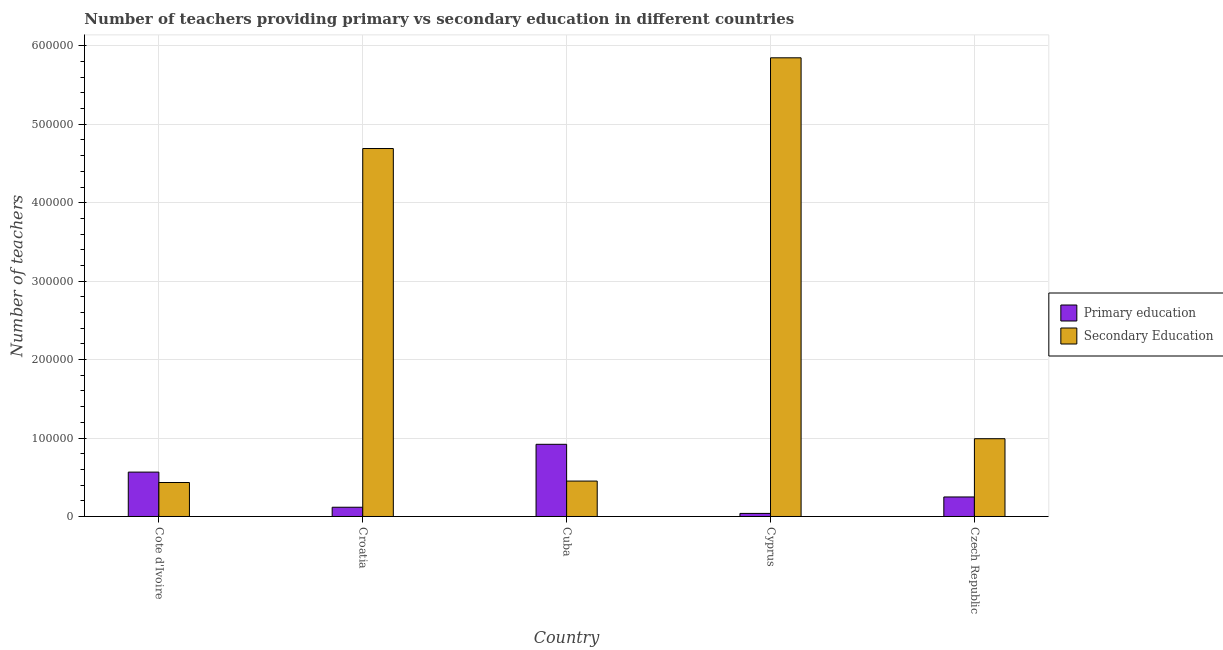How many groups of bars are there?
Provide a short and direct response. 5. How many bars are there on the 3rd tick from the right?
Your response must be concise. 2. What is the label of the 5th group of bars from the left?
Your answer should be compact. Czech Republic. In how many cases, is the number of bars for a given country not equal to the number of legend labels?
Ensure brevity in your answer.  0. What is the number of primary teachers in Cote d'Ivoire?
Provide a short and direct response. 5.66e+04. Across all countries, what is the maximum number of primary teachers?
Make the answer very short. 9.20e+04. Across all countries, what is the minimum number of primary teachers?
Ensure brevity in your answer.  3921. In which country was the number of primary teachers maximum?
Keep it short and to the point. Cuba. In which country was the number of primary teachers minimum?
Offer a terse response. Cyprus. What is the total number of secondary teachers in the graph?
Make the answer very short. 1.24e+06. What is the difference between the number of primary teachers in Cote d'Ivoire and that in Cyprus?
Offer a terse response. 5.27e+04. What is the difference between the number of primary teachers in Cyprus and the number of secondary teachers in Czech Republic?
Your answer should be compact. -9.52e+04. What is the average number of secondary teachers per country?
Provide a short and direct response. 2.48e+05. What is the difference between the number of secondary teachers and number of primary teachers in Cote d'Ivoire?
Your answer should be compact. -1.33e+04. In how many countries, is the number of primary teachers greater than 420000 ?
Your response must be concise. 0. What is the ratio of the number of secondary teachers in Croatia to that in Czech Republic?
Offer a very short reply. 4.73. Is the difference between the number of primary teachers in Cote d'Ivoire and Czech Republic greater than the difference between the number of secondary teachers in Cote d'Ivoire and Czech Republic?
Give a very brief answer. Yes. What is the difference between the highest and the second highest number of secondary teachers?
Provide a succinct answer. 1.16e+05. What is the difference between the highest and the lowest number of primary teachers?
Offer a very short reply. 8.81e+04. Is the sum of the number of primary teachers in Croatia and Cyprus greater than the maximum number of secondary teachers across all countries?
Ensure brevity in your answer.  No. What does the 2nd bar from the left in Czech Republic represents?
Your answer should be compact. Secondary Education. What does the 2nd bar from the right in Cyprus represents?
Keep it short and to the point. Primary education. Are all the bars in the graph horizontal?
Your answer should be very brief. No. How many countries are there in the graph?
Make the answer very short. 5. Are the values on the major ticks of Y-axis written in scientific E-notation?
Provide a succinct answer. No. Does the graph contain any zero values?
Your answer should be very brief. No. What is the title of the graph?
Keep it short and to the point. Number of teachers providing primary vs secondary education in different countries. What is the label or title of the X-axis?
Provide a succinct answer. Country. What is the label or title of the Y-axis?
Keep it short and to the point. Number of teachers. What is the Number of teachers of Primary education in Cote d'Ivoire?
Provide a succinct answer. 5.66e+04. What is the Number of teachers of Secondary Education in Cote d'Ivoire?
Make the answer very short. 4.33e+04. What is the Number of teachers in Primary education in Croatia?
Your answer should be compact. 1.18e+04. What is the Number of teachers in Secondary Education in Croatia?
Offer a terse response. 4.69e+05. What is the Number of teachers of Primary education in Cuba?
Ensure brevity in your answer.  9.20e+04. What is the Number of teachers of Secondary Education in Cuba?
Offer a very short reply. 4.51e+04. What is the Number of teachers in Primary education in Cyprus?
Your response must be concise. 3921. What is the Number of teachers in Secondary Education in Cyprus?
Your answer should be compact. 5.85e+05. What is the Number of teachers in Primary education in Czech Republic?
Offer a terse response. 2.49e+04. What is the Number of teachers of Secondary Education in Czech Republic?
Make the answer very short. 9.92e+04. Across all countries, what is the maximum Number of teachers of Primary education?
Offer a terse response. 9.20e+04. Across all countries, what is the maximum Number of teachers of Secondary Education?
Your answer should be very brief. 5.85e+05. Across all countries, what is the minimum Number of teachers of Primary education?
Your answer should be very brief. 3921. Across all countries, what is the minimum Number of teachers of Secondary Education?
Offer a terse response. 4.33e+04. What is the total Number of teachers in Primary education in the graph?
Your response must be concise. 1.89e+05. What is the total Number of teachers of Secondary Education in the graph?
Your response must be concise. 1.24e+06. What is the difference between the Number of teachers of Primary education in Cote d'Ivoire and that in Croatia?
Your answer should be compact. 4.48e+04. What is the difference between the Number of teachers of Secondary Education in Cote d'Ivoire and that in Croatia?
Offer a very short reply. -4.26e+05. What is the difference between the Number of teachers of Primary education in Cote d'Ivoire and that in Cuba?
Provide a succinct answer. -3.54e+04. What is the difference between the Number of teachers in Secondary Education in Cote d'Ivoire and that in Cuba?
Your answer should be very brief. -1828. What is the difference between the Number of teachers in Primary education in Cote d'Ivoire and that in Cyprus?
Offer a terse response. 5.27e+04. What is the difference between the Number of teachers of Secondary Education in Cote d'Ivoire and that in Cyprus?
Give a very brief answer. -5.41e+05. What is the difference between the Number of teachers in Primary education in Cote d'Ivoire and that in Czech Republic?
Make the answer very short. 3.17e+04. What is the difference between the Number of teachers in Secondary Education in Cote d'Ivoire and that in Czech Republic?
Make the answer very short. -5.58e+04. What is the difference between the Number of teachers of Primary education in Croatia and that in Cuba?
Your response must be concise. -8.02e+04. What is the difference between the Number of teachers in Secondary Education in Croatia and that in Cuba?
Your answer should be compact. 4.24e+05. What is the difference between the Number of teachers of Primary education in Croatia and that in Cyprus?
Provide a short and direct response. 7861. What is the difference between the Number of teachers in Secondary Education in Croatia and that in Cyprus?
Your response must be concise. -1.16e+05. What is the difference between the Number of teachers of Primary education in Croatia and that in Czech Republic?
Provide a short and direct response. -1.31e+04. What is the difference between the Number of teachers in Secondary Education in Croatia and that in Czech Republic?
Your response must be concise. 3.70e+05. What is the difference between the Number of teachers of Primary education in Cuba and that in Cyprus?
Make the answer very short. 8.81e+04. What is the difference between the Number of teachers in Secondary Education in Cuba and that in Cyprus?
Offer a very short reply. -5.40e+05. What is the difference between the Number of teachers in Primary education in Cuba and that in Czech Republic?
Keep it short and to the point. 6.71e+04. What is the difference between the Number of teachers in Secondary Education in Cuba and that in Czech Republic?
Your answer should be compact. -5.40e+04. What is the difference between the Number of teachers of Primary education in Cyprus and that in Czech Republic?
Provide a short and direct response. -2.10e+04. What is the difference between the Number of teachers in Secondary Education in Cyprus and that in Czech Republic?
Make the answer very short. 4.86e+05. What is the difference between the Number of teachers in Primary education in Cote d'Ivoire and the Number of teachers in Secondary Education in Croatia?
Your answer should be compact. -4.13e+05. What is the difference between the Number of teachers of Primary education in Cote d'Ivoire and the Number of teachers of Secondary Education in Cuba?
Provide a succinct answer. 1.14e+04. What is the difference between the Number of teachers of Primary education in Cote d'Ivoire and the Number of teachers of Secondary Education in Cyprus?
Give a very brief answer. -5.28e+05. What is the difference between the Number of teachers in Primary education in Cote d'Ivoire and the Number of teachers in Secondary Education in Czech Republic?
Offer a terse response. -4.26e+04. What is the difference between the Number of teachers in Primary education in Croatia and the Number of teachers in Secondary Education in Cuba?
Your answer should be very brief. -3.34e+04. What is the difference between the Number of teachers of Primary education in Croatia and the Number of teachers of Secondary Education in Cyprus?
Provide a succinct answer. -5.73e+05. What is the difference between the Number of teachers in Primary education in Croatia and the Number of teachers in Secondary Education in Czech Republic?
Provide a succinct answer. -8.74e+04. What is the difference between the Number of teachers in Primary education in Cuba and the Number of teachers in Secondary Education in Cyprus?
Your answer should be very brief. -4.93e+05. What is the difference between the Number of teachers in Primary education in Cuba and the Number of teachers in Secondary Education in Czech Republic?
Give a very brief answer. -7138. What is the difference between the Number of teachers in Primary education in Cyprus and the Number of teachers in Secondary Education in Czech Republic?
Your answer should be very brief. -9.52e+04. What is the average Number of teachers of Primary education per country?
Provide a succinct answer. 3.78e+04. What is the average Number of teachers in Secondary Education per country?
Keep it short and to the point. 2.48e+05. What is the difference between the Number of teachers in Primary education and Number of teachers in Secondary Education in Cote d'Ivoire?
Make the answer very short. 1.33e+04. What is the difference between the Number of teachers of Primary education and Number of teachers of Secondary Education in Croatia?
Ensure brevity in your answer.  -4.57e+05. What is the difference between the Number of teachers of Primary education and Number of teachers of Secondary Education in Cuba?
Ensure brevity in your answer.  4.69e+04. What is the difference between the Number of teachers of Primary education and Number of teachers of Secondary Education in Cyprus?
Ensure brevity in your answer.  -5.81e+05. What is the difference between the Number of teachers of Primary education and Number of teachers of Secondary Education in Czech Republic?
Give a very brief answer. -7.43e+04. What is the ratio of the Number of teachers in Primary education in Cote d'Ivoire to that in Croatia?
Provide a succinct answer. 4.8. What is the ratio of the Number of teachers in Secondary Education in Cote d'Ivoire to that in Croatia?
Give a very brief answer. 0.09. What is the ratio of the Number of teachers in Primary education in Cote d'Ivoire to that in Cuba?
Offer a very short reply. 0.61. What is the ratio of the Number of teachers of Secondary Education in Cote d'Ivoire to that in Cuba?
Provide a succinct answer. 0.96. What is the ratio of the Number of teachers of Primary education in Cote d'Ivoire to that in Cyprus?
Ensure brevity in your answer.  14.43. What is the ratio of the Number of teachers in Secondary Education in Cote d'Ivoire to that in Cyprus?
Keep it short and to the point. 0.07. What is the ratio of the Number of teachers in Primary education in Cote d'Ivoire to that in Czech Republic?
Provide a succinct answer. 2.27. What is the ratio of the Number of teachers of Secondary Education in Cote d'Ivoire to that in Czech Republic?
Offer a terse response. 0.44. What is the ratio of the Number of teachers of Primary education in Croatia to that in Cuba?
Provide a short and direct response. 0.13. What is the ratio of the Number of teachers of Secondary Education in Croatia to that in Cuba?
Your response must be concise. 10.39. What is the ratio of the Number of teachers in Primary education in Croatia to that in Cyprus?
Offer a very short reply. 3. What is the ratio of the Number of teachers in Secondary Education in Croatia to that in Cyprus?
Give a very brief answer. 0.8. What is the ratio of the Number of teachers in Primary education in Croatia to that in Czech Republic?
Provide a short and direct response. 0.47. What is the ratio of the Number of teachers of Secondary Education in Croatia to that in Czech Republic?
Give a very brief answer. 4.73. What is the ratio of the Number of teachers in Primary education in Cuba to that in Cyprus?
Make the answer very short. 23.47. What is the ratio of the Number of teachers in Secondary Education in Cuba to that in Cyprus?
Give a very brief answer. 0.08. What is the ratio of the Number of teachers in Primary education in Cuba to that in Czech Republic?
Provide a short and direct response. 3.7. What is the ratio of the Number of teachers in Secondary Education in Cuba to that in Czech Republic?
Ensure brevity in your answer.  0.46. What is the ratio of the Number of teachers of Primary education in Cyprus to that in Czech Republic?
Ensure brevity in your answer.  0.16. What is the ratio of the Number of teachers in Secondary Education in Cyprus to that in Czech Republic?
Ensure brevity in your answer.  5.9. What is the difference between the highest and the second highest Number of teachers of Primary education?
Provide a succinct answer. 3.54e+04. What is the difference between the highest and the second highest Number of teachers in Secondary Education?
Ensure brevity in your answer.  1.16e+05. What is the difference between the highest and the lowest Number of teachers in Primary education?
Keep it short and to the point. 8.81e+04. What is the difference between the highest and the lowest Number of teachers in Secondary Education?
Offer a terse response. 5.41e+05. 